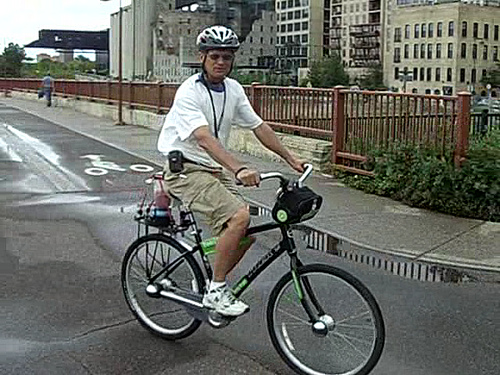Can you identify any safety features or accessories that the cyclist is using? Certainly, the cyclist is wearing a helmet, a critical safety accessory for head protection. Enhancing visibility, he has bright green bands around his ankles and is wearing light-colored shoes. On the bike, there are reflectors on the wheels, and the handlebar appears to have a mount, possibly for a light or a navigation device to assist during his travels. 